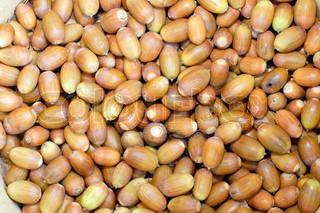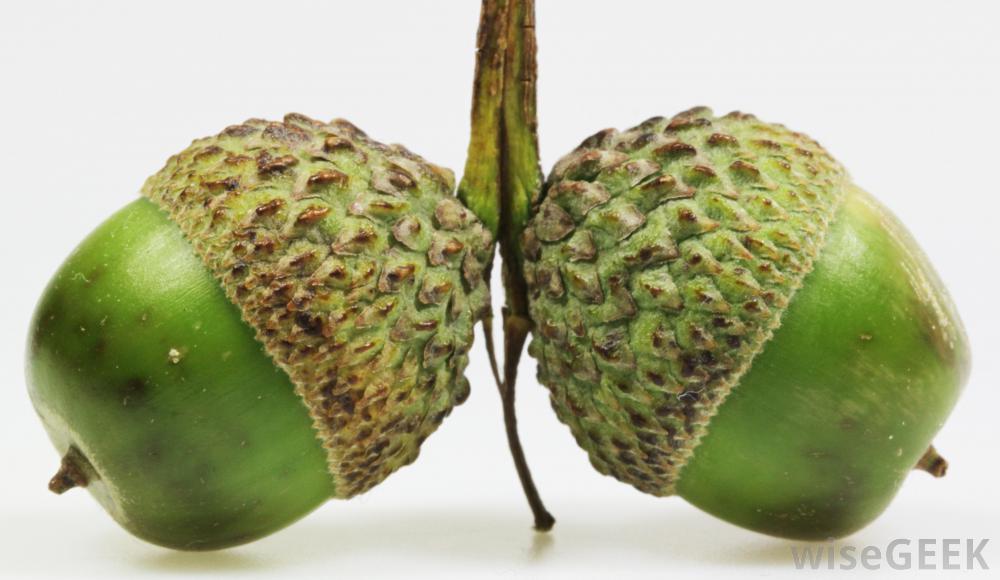The first image is the image on the left, the second image is the image on the right. Evaluate the accuracy of this statement regarding the images: "There are two green acorns and green acorn tops still attach to each other". Is it true? Answer yes or no. Yes. The first image is the image on the left, the second image is the image on the right. Examine the images to the left and right. Is the description "The right image features exactly two green-skinned acorns with their green caps back-to-back." accurate? Answer yes or no. Yes. 